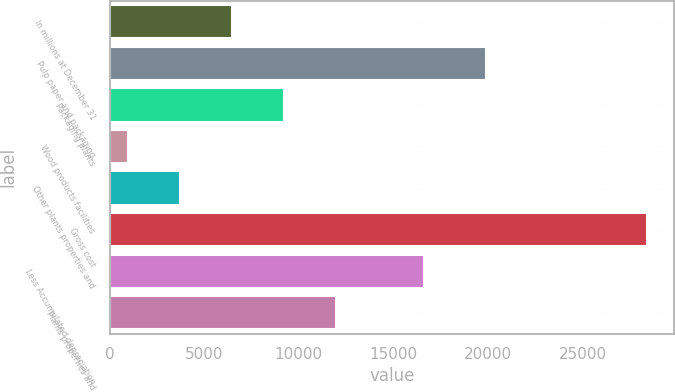Convert chart to OTSL. <chart><loc_0><loc_0><loc_500><loc_500><bar_chart><fcel>In millions at December 31<fcel>Pulp paper and packaging<fcel>Packaging plants<fcel>Wood products facilities<fcel>Other plants properties and<fcel>Gross cost<fcel>Less Accumulated depreciation<fcel>Plants properties and<nl><fcel>6465.2<fcel>19865<fcel>9208.8<fcel>978<fcel>3721.6<fcel>28414<fcel>16613<fcel>11952.4<nl></chart> 